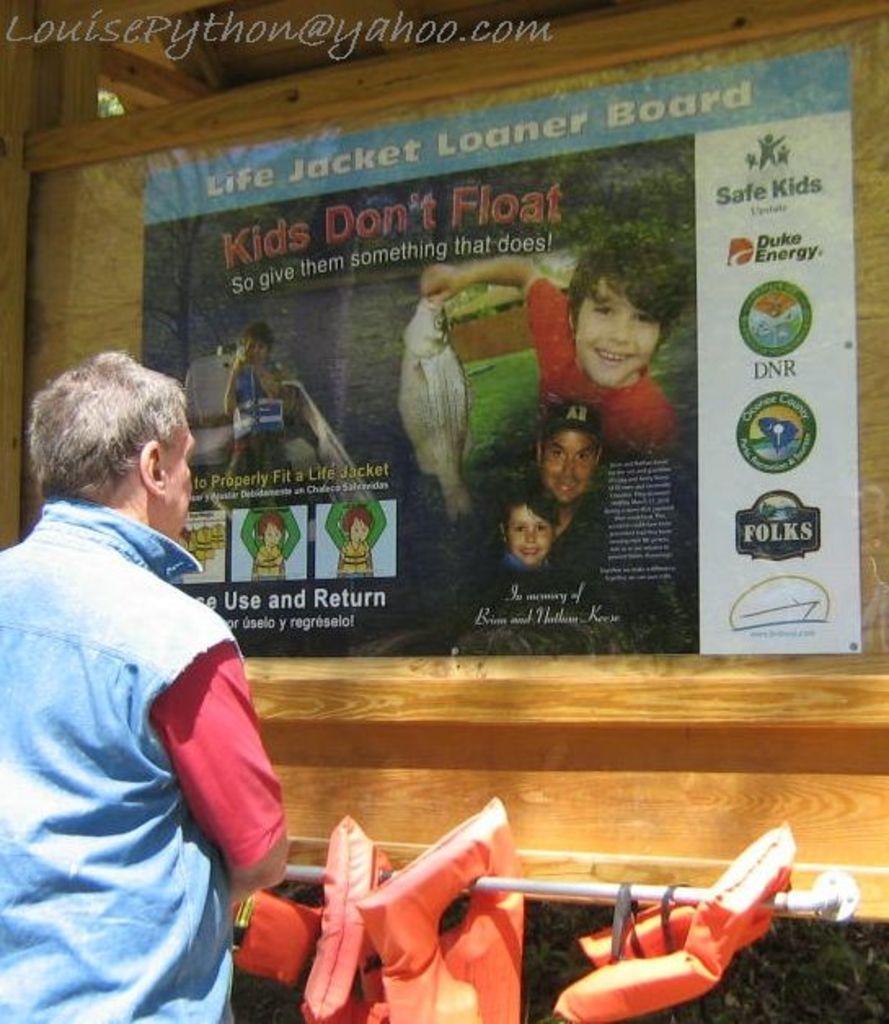How would you summarize this image in a sentence or two? In this image I see a person over here who is standing and I see the orange color things on this rod. In the background I see the poster over here on which something is written and I see the logos and I see pictures of few persons and I see that this child is holding a fish and I see the watermark over here. 